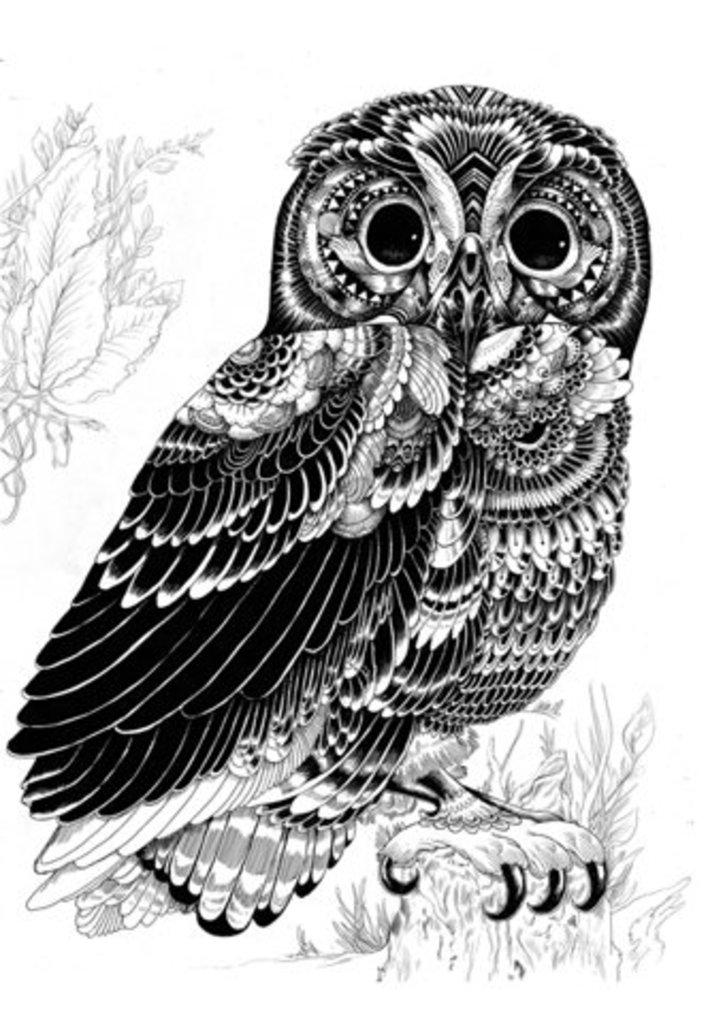What type of art is present in the image? There is owl art, leaves art, and flower art visible in the image. Can you describe the owl art in the image? The owl art is not described in detail, but it is mentioned as being present in the image. What other types of art can be seen in the image besides the owl art? Leaves art and flower art are also visible in the image. Is there a rain art visible in the image? There is no mention of rain art in the provided facts, so it cannot be confirmed that rain art is present in the image. Does the existence of the art in the image prove the existence of the artist? The existence of the art in the image does not necessarily prove the existence of the artist, as the artist could be unknown or the art could be a reproduction. 